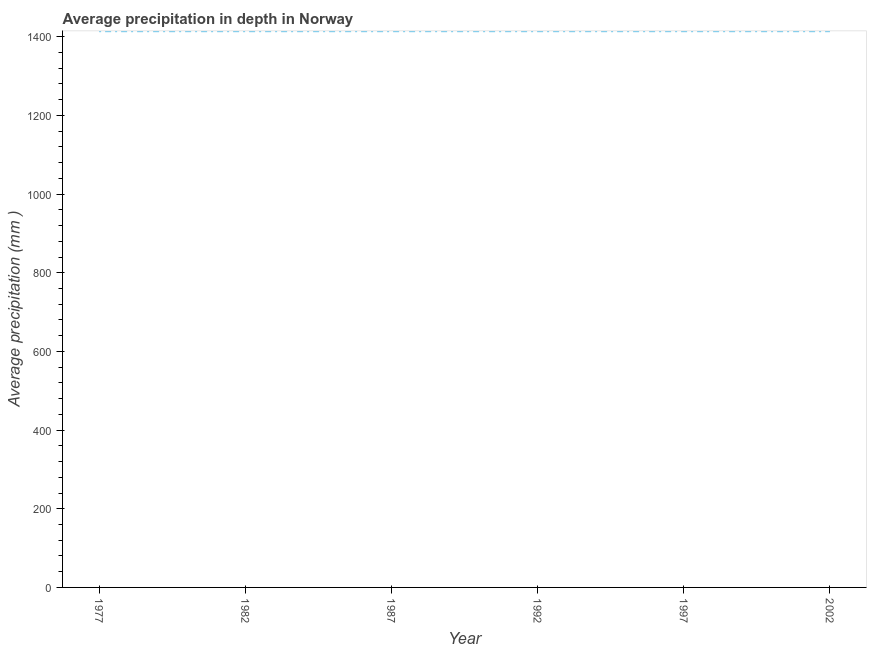What is the average precipitation in depth in 1992?
Keep it short and to the point. 1414. Across all years, what is the maximum average precipitation in depth?
Keep it short and to the point. 1414. Across all years, what is the minimum average precipitation in depth?
Provide a succinct answer. 1414. In which year was the average precipitation in depth minimum?
Ensure brevity in your answer.  1977. What is the sum of the average precipitation in depth?
Offer a terse response. 8484. What is the average average precipitation in depth per year?
Your response must be concise. 1414. What is the median average precipitation in depth?
Keep it short and to the point. 1414. Is the average precipitation in depth in 1997 less than that in 2002?
Ensure brevity in your answer.  No. What is the difference between the highest and the second highest average precipitation in depth?
Provide a succinct answer. 0. Does the average precipitation in depth monotonically increase over the years?
Provide a succinct answer. No. How many years are there in the graph?
Your answer should be very brief. 6. What is the difference between two consecutive major ticks on the Y-axis?
Make the answer very short. 200. Does the graph contain any zero values?
Offer a terse response. No. What is the title of the graph?
Your response must be concise. Average precipitation in depth in Norway. What is the label or title of the X-axis?
Provide a short and direct response. Year. What is the label or title of the Y-axis?
Offer a very short reply. Average precipitation (mm ). What is the Average precipitation (mm ) of 1977?
Keep it short and to the point. 1414. What is the Average precipitation (mm ) in 1982?
Your answer should be compact. 1414. What is the Average precipitation (mm ) of 1987?
Your response must be concise. 1414. What is the Average precipitation (mm ) of 1992?
Provide a short and direct response. 1414. What is the Average precipitation (mm ) of 1997?
Offer a very short reply. 1414. What is the Average precipitation (mm ) of 2002?
Provide a short and direct response. 1414. What is the difference between the Average precipitation (mm ) in 1977 and 1982?
Provide a succinct answer. 0. What is the difference between the Average precipitation (mm ) in 1977 and 1997?
Your response must be concise. 0. What is the difference between the Average precipitation (mm ) in 1977 and 2002?
Ensure brevity in your answer.  0. What is the difference between the Average precipitation (mm ) in 1982 and 1992?
Your answer should be compact. 0. What is the difference between the Average precipitation (mm ) in 1982 and 1997?
Make the answer very short. 0. What is the difference between the Average precipitation (mm ) in 1982 and 2002?
Provide a succinct answer. 0. What is the difference between the Average precipitation (mm ) in 1987 and 1992?
Ensure brevity in your answer.  0. What is the difference between the Average precipitation (mm ) in 1987 and 2002?
Ensure brevity in your answer.  0. What is the difference between the Average precipitation (mm ) in 1992 and 1997?
Give a very brief answer. 0. What is the difference between the Average precipitation (mm ) in 1997 and 2002?
Provide a short and direct response. 0. What is the ratio of the Average precipitation (mm ) in 1977 to that in 1982?
Offer a terse response. 1. What is the ratio of the Average precipitation (mm ) in 1977 to that in 1987?
Offer a terse response. 1. What is the ratio of the Average precipitation (mm ) in 1977 to that in 1992?
Offer a terse response. 1. What is the ratio of the Average precipitation (mm ) in 1982 to that in 1987?
Offer a very short reply. 1. What is the ratio of the Average precipitation (mm ) in 1982 to that in 1992?
Your response must be concise. 1. What is the ratio of the Average precipitation (mm ) in 1992 to that in 2002?
Provide a short and direct response. 1. What is the ratio of the Average precipitation (mm ) in 1997 to that in 2002?
Give a very brief answer. 1. 